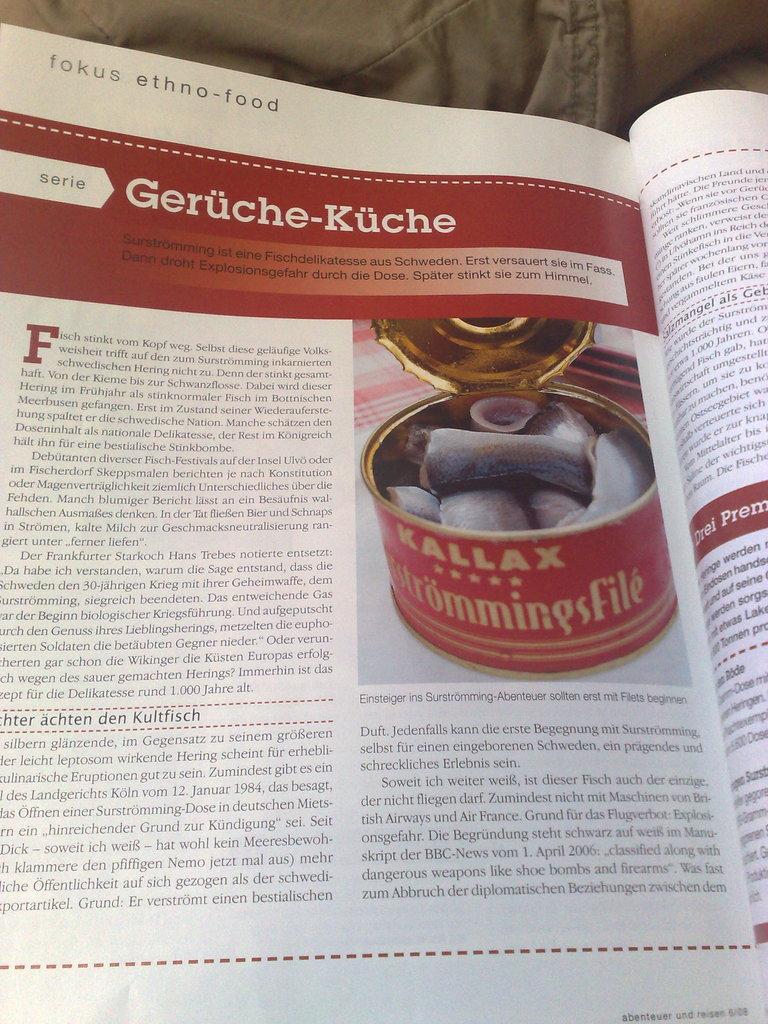What do the silver letters say?
Keep it short and to the point. Unanswerable. What is the title of this section?
Your answer should be very brief. Geruche-kuche. 